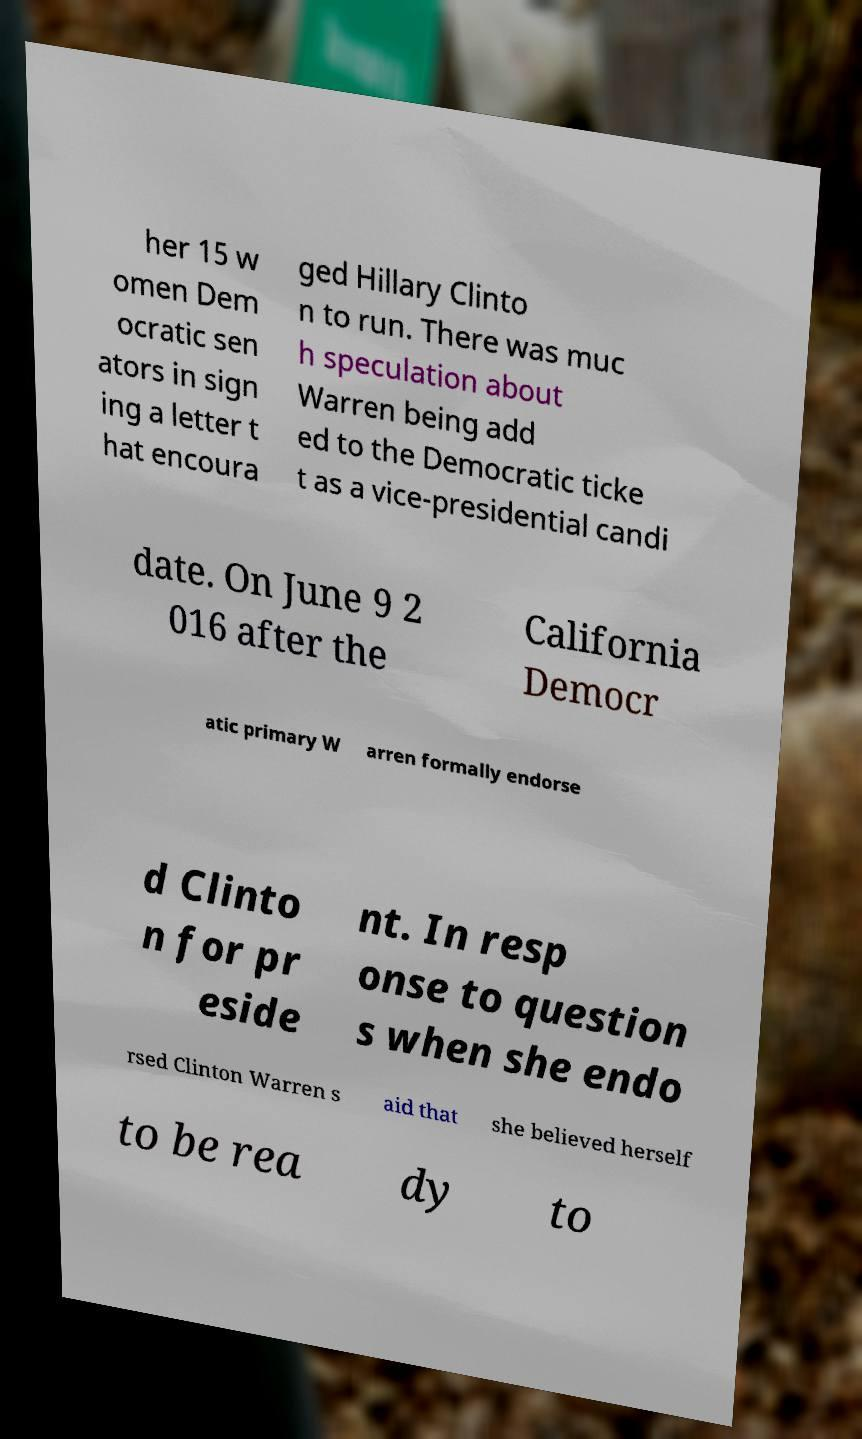Could you assist in decoding the text presented in this image and type it out clearly? her 15 w omen Dem ocratic sen ators in sign ing a letter t hat encoura ged Hillary Clinto n to run. There was muc h speculation about Warren being add ed to the Democratic ticke t as a vice-presidential candi date. On June 9 2 016 after the California Democr atic primary W arren formally endorse d Clinto n for pr eside nt. In resp onse to question s when she endo rsed Clinton Warren s aid that she believed herself to be rea dy to 